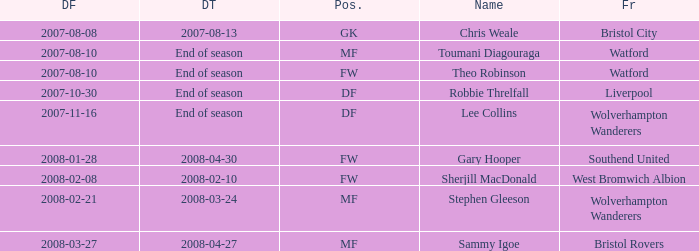What was the Date From for Theo Robinson, who was with the team until the end of season? 2007-08-10. 